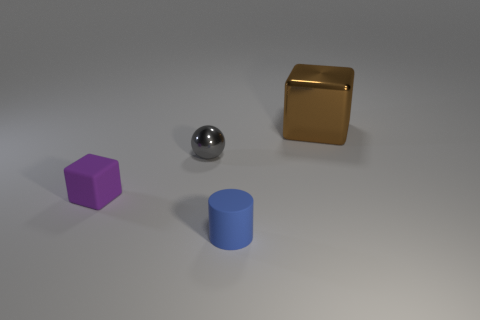There is a rubber thing that is right of the cube in front of the gray metallic ball; how big is it?
Ensure brevity in your answer.  Small. Is there a small gray object?
Ensure brevity in your answer.  Yes. There is a tiny object to the left of the tiny shiny object; what number of big objects are to the right of it?
Your answer should be very brief. 1. What shape is the rubber thing that is on the right side of the small metal ball?
Make the answer very short. Cylinder. There is a thing that is in front of the rubber object on the left side of the metal object that is in front of the large object; what is its material?
Make the answer very short. Rubber. How many other objects are there of the same size as the metal block?
Provide a succinct answer. 0. What material is the other large thing that is the same shape as the purple thing?
Offer a very short reply. Metal. What color is the big metal thing?
Give a very brief answer. Brown. The tiny rubber object that is right of the metallic object that is on the left side of the large object is what color?
Offer a very short reply. Blue. Is the color of the shiny block the same as the tiny rubber thing that is behind the tiny matte cylinder?
Offer a very short reply. No. 